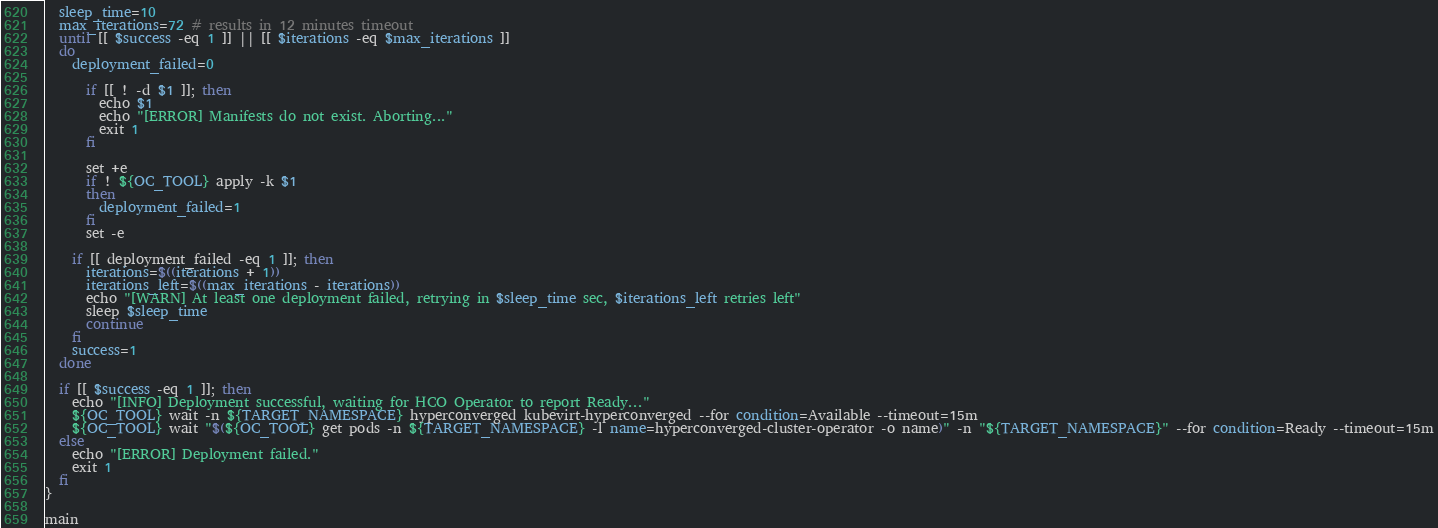Convert code to text. <code><loc_0><loc_0><loc_500><loc_500><_Bash_>  sleep_time=10
  max_iterations=72 # results in 12 minutes timeout
  until [[ $success -eq 1 ]] || [[ $iterations -eq $max_iterations ]]
  do
    deployment_failed=0

      if [[ ! -d $1 ]]; then
        echo $1
        echo "[ERROR] Manifests do not exist. Aborting..."
        exit 1
      fi

      set +e
      if ! ${OC_TOOL} apply -k $1
      then
        deployment_failed=1
      fi
      set -e

    if [[ deployment_failed -eq 1 ]]; then
      iterations=$((iterations + 1))
      iterations_left=$((max_iterations - iterations))
      echo "[WARN] At least one deployment failed, retrying in $sleep_time sec, $iterations_left retries left"
      sleep $sleep_time
      continue
    fi
    success=1
  done

  if [[ $success -eq 1 ]]; then
    echo "[INFO] Deployment successful, waiting for HCO Operator to report Ready..."
    ${OC_TOOL} wait -n ${TARGET_NAMESPACE} hyperconverged kubevirt-hyperconverged --for condition=Available --timeout=15m
    ${OC_TOOL} wait "$(${OC_TOOL} get pods -n ${TARGET_NAMESPACE} -l name=hyperconverged-cluster-operator -o name)" -n "${TARGET_NAMESPACE}" --for condition=Ready --timeout=15m
  else
    echo "[ERROR] Deployment failed."
    exit 1
  fi
}

main
</code> 